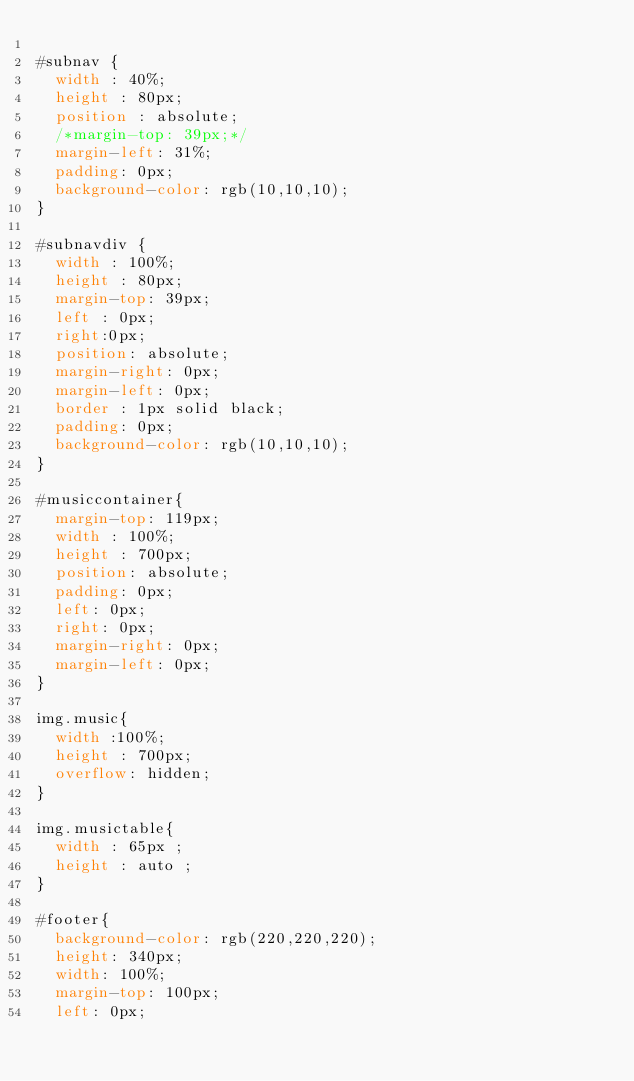Convert code to text. <code><loc_0><loc_0><loc_500><loc_500><_CSS_>
#subnav {
	width : 40%;
	height : 80px;
	position : absolute;
	/*margin-top: 39px;*/
	margin-left: 31%;
	padding: 0px;
	background-color: rgb(10,10,10);
}

#subnavdiv {
	width : 100%;
	height : 80px;
	margin-top: 39px;
	left : 0px;
	right:0px;
	position: absolute;
	margin-right: 0px;
	margin-left: 0px;
	border : 1px solid black;
	padding: 0px;
	background-color: rgb(10,10,10);
}

#musiccontainer{
	margin-top: 119px;
	width : 100%;
	height : 700px;
	position: absolute;
	padding: 0px;
	left: 0px;
	right: 0px;
	margin-right: 0px;
	margin-left: 0px;
}

img.music{
	width :100%;
	height : 700px;
	overflow: hidden;
}

img.musictable{
	width : 65px ; 
	height : auto ;
}

#footer{
	background-color: rgb(220,220,220);
	height: 340px;
	width: 100%;
	margin-top: 100px;
	left: 0px;</code> 